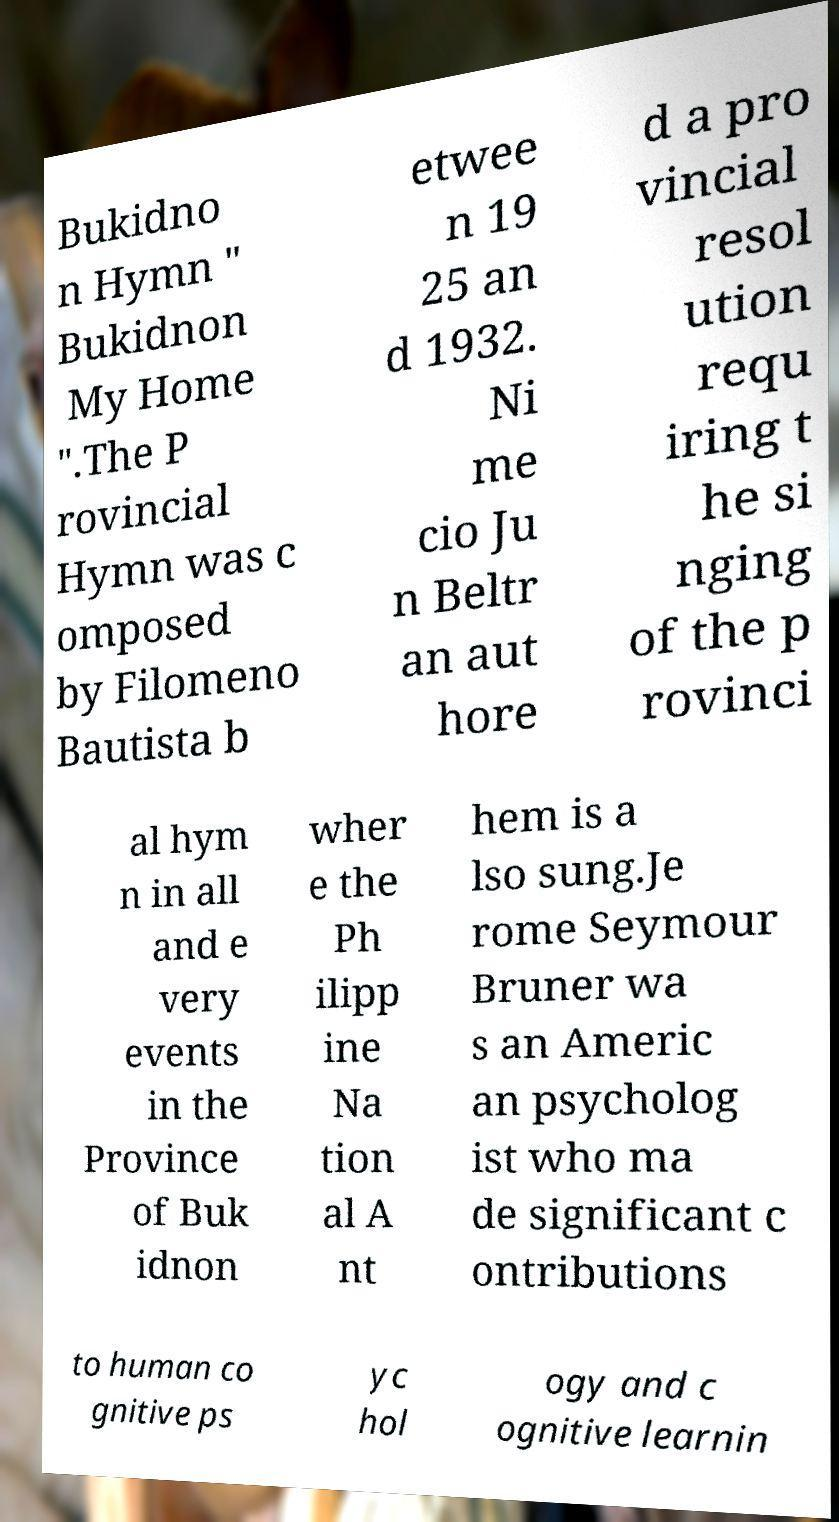I need the written content from this picture converted into text. Can you do that? Bukidno n Hymn " Bukidnon My Home ".The P rovincial Hymn was c omposed by Filomeno Bautista b etwee n 19 25 an d 1932. Ni me cio Ju n Beltr an aut hore d a pro vincial resol ution requ iring t he si nging of the p rovinci al hym n in all and e very events in the Province of Buk idnon wher e the Ph ilipp ine Na tion al A nt hem is a lso sung.Je rome Seymour Bruner wa s an Americ an psycholog ist who ma de significant c ontributions to human co gnitive ps yc hol ogy and c ognitive learnin 